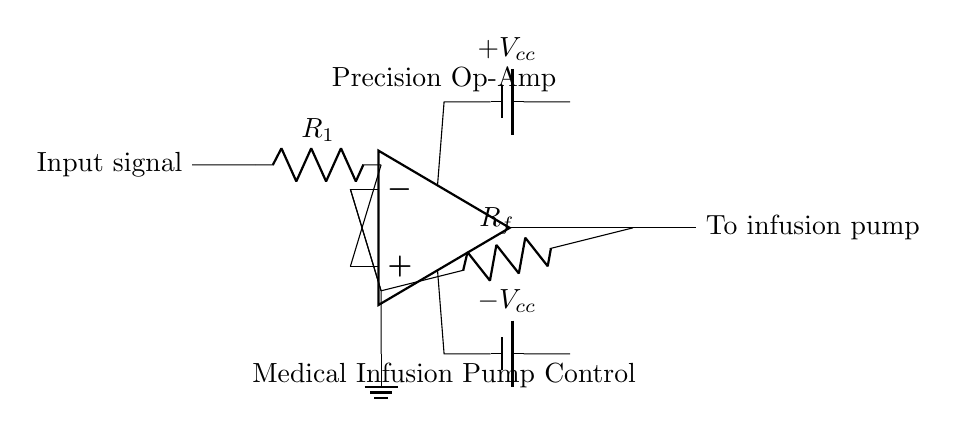What is the role of the operational amplifier in this circuit? The operational amplifier amplifies the input signal, providing precise control over the output that drives the infusion pump, enhancing the accuracy of the infusion process.
Answer: amplifies What are the resistor values used in the circuit? The circuit diagram does not specify numeric values for the resistors R1 and Rf; they are labeled generically. Specific values would need to be determined based on the application's requirements.
Answer: unspecified What is the output connection labeled as? The output connection is labeled "To infusion pump," indicating where the controlled output from the amplifier is directed.
Answer: To infusion pump How is the operational amplifier powered? The operational amplifier is powered by two batteries, labeled as positive and negative voltage supply, providing the necessary voltage for its operation.
Answer: two batteries What does the ground symbol represent in this circuit? The ground symbol indicates a reference point in the circuit, typically considered to be zero volts, which stabilizes the circuit and provides a return path for current.
Answer: zero volts What type of feedback does this operational amplifier circuit utilize? This operational amplifier circuit utilizes negative feedback, as indicated by the connection from the output to the inverting input, which stabilizes the gain and enhances linearity.
Answer: negative feedback What is the purpose of the resistor Rf in this circuit? The resistor Rf is part of the feedback network, which sets the gain of the operational amplifier, determining the level of amplification applied to the input signal.
Answer: sets gain 